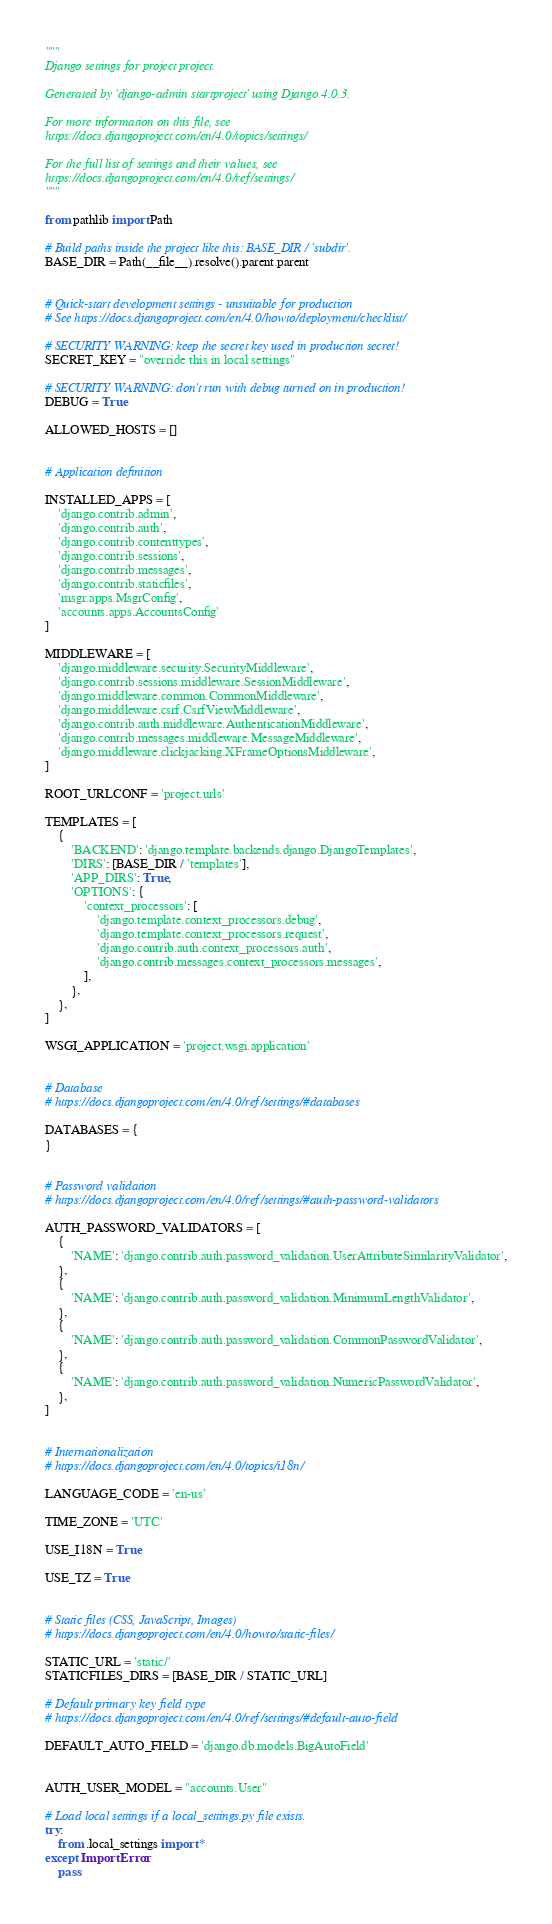Convert code to text. <code><loc_0><loc_0><loc_500><loc_500><_Python_>"""
Django settings for project project.

Generated by 'django-admin startproject' using Django 4.0.3.

For more information on this file, see
https://docs.djangoproject.com/en/4.0/topics/settings/

For the full list of settings and their values, see
https://docs.djangoproject.com/en/4.0/ref/settings/
"""

from pathlib import Path

# Build paths inside the project like this: BASE_DIR / 'subdir'.
BASE_DIR = Path(__file__).resolve().parent.parent


# Quick-start development settings - unsuitable for production
# See https://docs.djangoproject.com/en/4.0/howto/deployment/checklist/

# SECURITY WARNING: keep the secret key used in production secret!
SECRET_KEY = "override this in local settings"

# SECURITY WARNING: don't run with debug turned on in production!
DEBUG = True

ALLOWED_HOSTS = []


# Application definition

INSTALLED_APPS = [
    'django.contrib.admin',
    'django.contrib.auth',
    'django.contrib.contenttypes',
    'django.contrib.sessions',
    'django.contrib.messages',
    'django.contrib.staticfiles',
    'msgr.apps.MsgrConfig',
    'accounts.apps.AccountsConfig'
]

MIDDLEWARE = [
    'django.middleware.security.SecurityMiddleware',
    'django.contrib.sessions.middleware.SessionMiddleware',
    'django.middleware.common.CommonMiddleware',
    'django.middleware.csrf.CsrfViewMiddleware',
    'django.contrib.auth.middleware.AuthenticationMiddleware',
    'django.contrib.messages.middleware.MessageMiddleware',
    'django.middleware.clickjacking.XFrameOptionsMiddleware',
]

ROOT_URLCONF = 'project.urls'

TEMPLATES = [
    {
        'BACKEND': 'django.template.backends.django.DjangoTemplates',
        'DIRS': [BASE_DIR / 'templates'],
        'APP_DIRS': True,
        'OPTIONS': {
            'context_processors': [
                'django.template.context_processors.debug',
                'django.template.context_processors.request',
                'django.contrib.auth.context_processors.auth',
                'django.contrib.messages.context_processors.messages',
            ],
        },
    },
]

WSGI_APPLICATION = 'project.wsgi.application'


# Database
# https://docs.djangoproject.com/en/4.0/ref/settings/#databases

DATABASES = {
}


# Password validation
# https://docs.djangoproject.com/en/4.0/ref/settings/#auth-password-validators

AUTH_PASSWORD_VALIDATORS = [
    {
        'NAME': 'django.contrib.auth.password_validation.UserAttributeSimilarityValidator',
    },
    {
        'NAME': 'django.contrib.auth.password_validation.MinimumLengthValidator',
    },
    {
        'NAME': 'django.contrib.auth.password_validation.CommonPasswordValidator',
    },
    {
        'NAME': 'django.contrib.auth.password_validation.NumericPasswordValidator',
    },
]


# Internationalization
# https://docs.djangoproject.com/en/4.0/topics/i18n/

LANGUAGE_CODE = 'en-us'

TIME_ZONE = 'UTC'

USE_I18N = True

USE_TZ = True


# Static files (CSS, JavaScript, Images)
# https://docs.djangoproject.com/en/4.0/howto/static-files/

STATIC_URL = 'static/'
STATICFILES_DIRS = [BASE_DIR / STATIC_URL]

# Default primary key field type
# https://docs.djangoproject.com/en/4.0/ref/settings/#default-auto-field

DEFAULT_AUTO_FIELD = 'django.db.models.BigAutoField'


AUTH_USER_MODEL = "accounts.User"

# Load local settings if a local_settings.py file exists.
try:
    from .local_settings import *
except ImportError:
    pass

</code> 